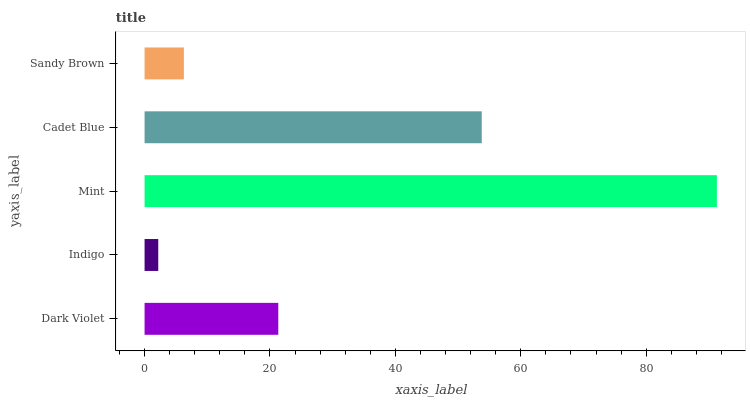Is Indigo the minimum?
Answer yes or no. Yes. Is Mint the maximum?
Answer yes or no. Yes. Is Mint the minimum?
Answer yes or no. No. Is Indigo the maximum?
Answer yes or no. No. Is Mint greater than Indigo?
Answer yes or no. Yes. Is Indigo less than Mint?
Answer yes or no. Yes. Is Indigo greater than Mint?
Answer yes or no. No. Is Mint less than Indigo?
Answer yes or no. No. Is Dark Violet the high median?
Answer yes or no. Yes. Is Dark Violet the low median?
Answer yes or no. Yes. Is Mint the high median?
Answer yes or no. No. Is Cadet Blue the low median?
Answer yes or no. No. 